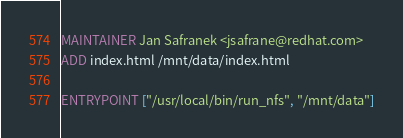Convert code to text. <code><loc_0><loc_0><loc_500><loc_500><_Dockerfile_>MAINTAINER Jan Safranek <jsafrane@redhat.com>
ADD index.html /mnt/data/index.html

ENTRYPOINT ["/usr/local/bin/run_nfs", "/mnt/data"]
</code> 